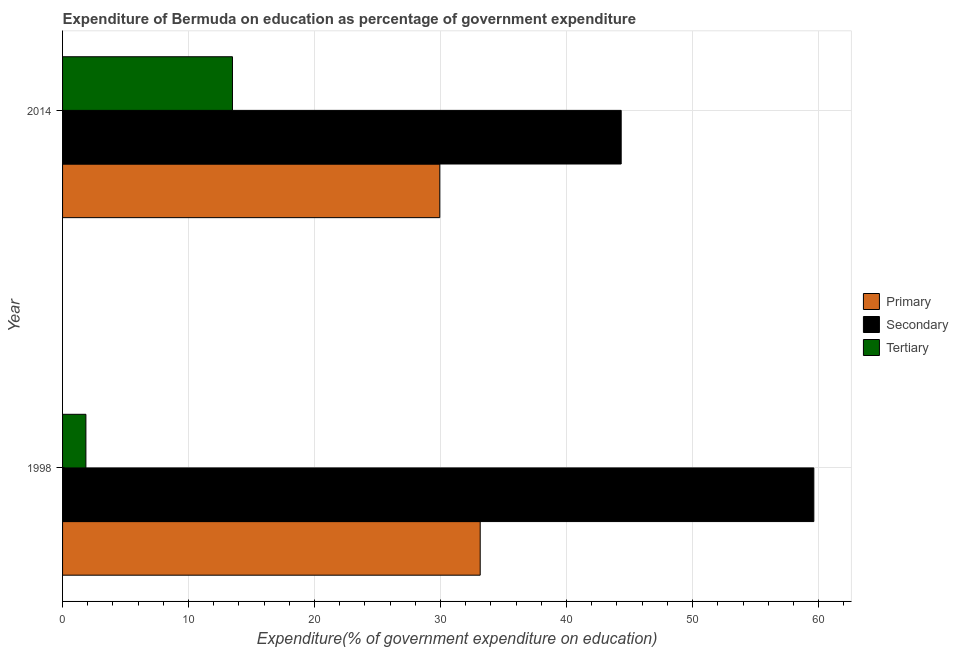How many groups of bars are there?
Offer a terse response. 2. Are the number of bars per tick equal to the number of legend labels?
Provide a short and direct response. Yes. How many bars are there on the 1st tick from the top?
Give a very brief answer. 3. How many bars are there on the 2nd tick from the bottom?
Your response must be concise. 3. What is the expenditure on primary education in 2014?
Offer a terse response. 29.94. Across all years, what is the maximum expenditure on primary education?
Provide a succinct answer. 33.14. Across all years, what is the minimum expenditure on primary education?
Your answer should be very brief. 29.94. In which year was the expenditure on tertiary education maximum?
Your response must be concise. 2014. What is the total expenditure on tertiary education in the graph?
Your response must be concise. 15.34. What is the difference between the expenditure on primary education in 1998 and that in 2014?
Provide a short and direct response. 3.21. What is the difference between the expenditure on secondary education in 2014 and the expenditure on primary education in 1998?
Offer a terse response. 11.19. What is the average expenditure on secondary education per year?
Give a very brief answer. 51.98. In the year 2014, what is the difference between the expenditure on secondary education and expenditure on primary education?
Keep it short and to the point. 14.4. In how many years, is the expenditure on secondary education greater than 2 %?
Offer a terse response. 2. What is the ratio of the expenditure on primary education in 1998 to that in 2014?
Offer a terse response. 1.11. In how many years, is the expenditure on tertiary education greater than the average expenditure on tertiary education taken over all years?
Keep it short and to the point. 1. What does the 3rd bar from the top in 1998 represents?
Your answer should be very brief. Primary. What does the 2nd bar from the bottom in 2014 represents?
Your answer should be very brief. Secondary. Is it the case that in every year, the sum of the expenditure on primary education and expenditure on secondary education is greater than the expenditure on tertiary education?
Provide a succinct answer. Yes. How many bars are there?
Your answer should be compact. 6. Are all the bars in the graph horizontal?
Offer a very short reply. Yes. How many years are there in the graph?
Provide a short and direct response. 2. Are the values on the major ticks of X-axis written in scientific E-notation?
Provide a succinct answer. No. Where does the legend appear in the graph?
Provide a short and direct response. Center right. How many legend labels are there?
Offer a terse response. 3. What is the title of the graph?
Give a very brief answer. Expenditure of Bermuda on education as percentage of government expenditure. What is the label or title of the X-axis?
Keep it short and to the point. Expenditure(% of government expenditure on education). What is the label or title of the Y-axis?
Give a very brief answer. Year. What is the Expenditure(% of government expenditure on education) of Primary in 1998?
Your answer should be very brief. 33.14. What is the Expenditure(% of government expenditure on education) in Secondary in 1998?
Provide a succinct answer. 59.62. What is the Expenditure(% of government expenditure on education) of Tertiary in 1998?
Make the answer very short. 1.85. What is the Expenditure(% of government expenditure on education) of Primary in 2014?
Your response must be concise. 29.94. What is the Expenditure(% of government expenditure on education) in Secondary in 2014?
Keep it short and to the point. 44.33. What is the Expenditure(% of government expenditure on education) of Tertiary in 2014?
Your response must be concise. 13.48. Across all years, what is the maximum Expenditure(% of government expenditure on education) of Primary?
Offer a very short reply. 33.14. Across all years, what is the maximum Expenditure(% of government expenditure on education) of Secondary?
Your answer should be very brief. 59.62. Across all years, what is the maximum Expenditure(% of government expenditure on education) in Tertiary?
Your answer should be very brief. 13.48. Across all years, what is the minimum Expenditure(% of government expenditure on education) of Primary?
Your answer should be very brief. 29.94. Across all years, what is the minimum Expenditure(% of government expenditure on education) of Secondary?
Ensure brevity in your answer.  44.33. Across all years, what is the minimum Expenditure(% of government expenditure on education) of Tertiary?
Provide a succinct answer. 1.85. What is the total Expenditure(% of government expenditure on education) in Primary in the graph?
Keep it short and to the point. 63.08. What is the total Expenditure(% of government expenditure on education) of Secondary in the graph?
Keep it short and to the point. 103.96. What is the total Expenditure(% of government expenditure on education) in Tertiary in the graph?
Provide a short and direct response. 15.34. What is the difference between the Expenditure(% of government expenditure on education) in Primary in 1998 and that in 2014?
Your answer should be compact. 3.21. What is the difference between the Expenditure(% of government expenditure on education) of Secondary in 1998 and that in 2014?
Provide a short and direct response. 15.29. What is the difference between the Expenditure(% of government expenditure on education) of Tertiary in 1998 and that in 2014?
Offer a very short reply. -11.63. What is the difference between the Expenditure(% of government expenditure on education) in Primary in 1998 and the Expenditure(% of government expenditure on education) in Secondary in 2014?
Keep it short and to the point. -11.19. What is the difference between the Expenditure(% of government expenditure on education) of Primary in 1998 and the Expenditure(% of government expenditure on education) of Tertiary in 2014?
Provide a short and direct response. 19.66. What is the difference between the Expenditure(% of government expenditure on education) of Secondary in 1998 and the Expenditure(% of government expenditure on education) of Tertiary in 2014?
Provide a succinct answer. 46.14. What is the average Expenditure(% of government expenditure on education) of Primary per year?
Your answer should be compact. 31.54. What is the average Expenditure(% of government expenditure on education) of Secondary per year?
Keep it short and to the point. 51.98. What is the average Expenditure(% of government expenditure on education) of Tertiary per year?
Your response must be concise. 7.67. In the year 1998, what is the difference between the Expenditure(% of government expenditure on education) in Primary and Expenditure(% of government expenditure on education) in Secondary?
Offer a terse response. -26.48. In the year 1998, what is the difference between the Expenditure(% of government expenditure on education) of Primary and Expenditure(% of government expenditure on education) of Tertiary?
Your answer should be very brief. 31.29. In the year 1998, what is the difference between the Expenditure(% of government expenditure on education) in Secondary and Expenditure(% of government expenditure on education) in Tertiary?
Your answer should be very brief. 57.77. In the year 2014, what is the difference between the Expenditure(% of government expenditure on education) of Primary and Expenditure(% of government expenditure on education) of Secondary?
Your answer should be compact. -14.4. In the year 2014, what is the difference between the Expenditure(% of government expenditure on education) of Primary and Expenditure(% of government expenditure on education) of Tertiary?
Provide a short and direct response. 16.45. In the year 2014, what is the difference between the Expenditure(% of government expenditure on education) of Secondary and Expenditure(% of government expenditure on education) of Tertiary?
Your response must be concise. 30.85. What is the ratio of the Expenditure(% of government expenditure on education) of Primary in 1998 to that in 2014?
Your answer should be compact. 1.11. What is the ratio of the Expenditure(% of government expenditure on education) in Secondary in 1998 to that in 2014?
Keep it short and to the point. 1.34. What is the ratio of the Expenditure(% of government expenditure on education) in Tertiary in 1998 to that in 2014?
Your response must be concise. 0.14. What is the difference between the highest and the second highest Expenditure(% of government expenditure on education) in Primary?
Provide a succinct answer. 3.21. What is the difference between the highest and the second highest Expenditure(% of government expenditure on education) in Secondary?
Provide a succinct answer. 15.29. What is the difference between the highest and the second highest Expenditure(% of government expenditure on education) in Tertiary?
Keep it short and to the point. 11.63. What is the difference between the highest and the lowest Expenditure(% of government expenditure on education) of Primary?
Offer a terse response. 3.21. What is the difference between the highest and the lowest Expenditure(% of government expenditure on education) of Secondary?
Ensure brevity in your answer.  15.29. What is the difference between the highest and the lowest Expenditure(% of government expenditure on education) of Tertiary?
Keep it short and to the point. 11.63. 